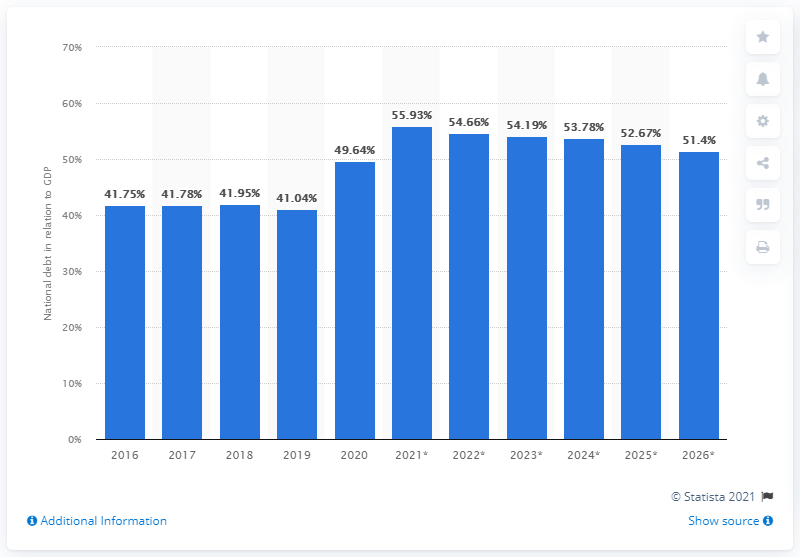Identify some key points in this picture. The national debt of Thailand ended in 2020. In 2020, the national debt of Thailand accounted for approximately 49.64% of the country's Gross Domestic Product (GDP). 